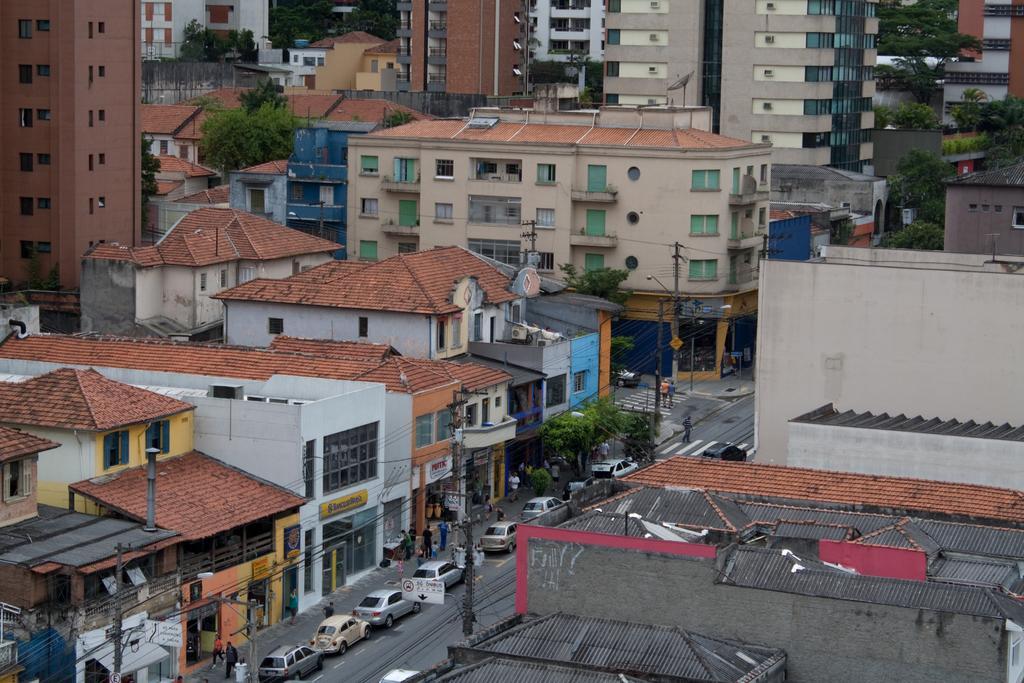How would you summarize this image in a sentence or two? In this picture we can see few vehicles, poles, cables and people, in the background we can see few trees and buildings. 